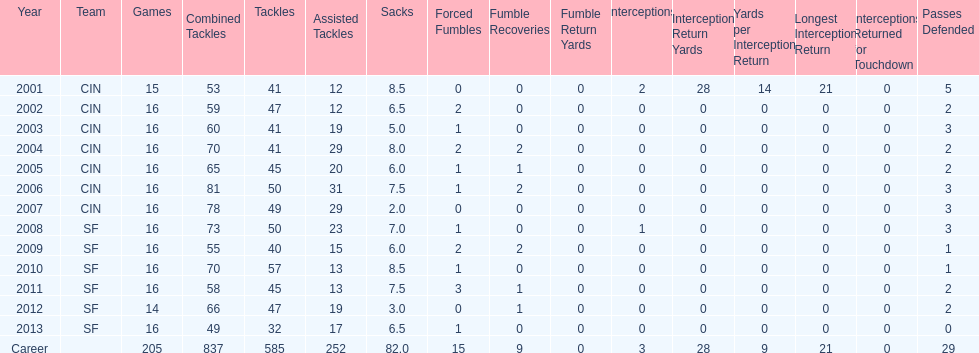Could you parse the entire table as a dict? {'header': ['Year', 'Team', 'Games', 'Combined Tackles', 'Tackles', 'Assisted Tackles', 'Sacks', 'Forced Fumbles', 'Fumble Recoveries', 'Fumble Return Yards', 'Interceptions', 'Interception Return Yards', 'Yards per Interception Return', 'Longest Interception Return', 'Interceptions Returned for Touchdown', 'Passes Defended'], 'rows': [['2001', 'CIN', '15', '53', '41', '12', '8.5', '0', '0', '0', '2', '28', '14', '21', '0', '5'], ['2002', 'CIN', '16', '59', '47', '12', '6.5', '2', '0', '0', '0', '0', '0', '0', '0', '2'], ['2003', 'CIN', '16', '60', '41', '19', '5.0', '1', '0', '0', '0', '0', '0', '0', '0', '3'], ['2004', 'CIN', '16', '70', '41', '29', '8.0', '2', '2', '0', '0', '0', '0', '0', '0', '2'], ['2005', 'CIN', '16', '65', '45', '20', '6.0', '1', '1', '0', '0', '0', '0', '0', '0', '2'], ['2006', 'CIN', '16', '81', '50', '31', '7.5', '1', '2', '0', '0', '0', '0', '0', '0', '3'], ['2007', 'CIN', '16', '78', '49', '29', '2.0', '0', '0', '0', '0', '0', '0', '0', '0', '3'], ['2008', 'SF', '16', '73', '50', '23', '7.0', '1', '0', '0', '1', '0', '0', '0', '0', '3'], ['2009', 'SF', '16', '55', '40', '15', '6.0', '2', '2', '0', '0', '0', '0', '0', '0', '1'], ['2010', 'SF', '16', '70', '57', '13', '8.5', '1', '0', '0', '0', '0', '0', '0', '0', '1'], ['2011', 'SF', '16', '58', '45', '13', '7.5', '3', '1', '0', '0', '0', '0', '0', '0', '2'], ['2012', 'SF', '14', '66', '47', '19', '3.0', '0', '1', '0', '0', '0', '0', '0', '0', '2'], ['2013', 'SF', '16', '49', '32', '17', '6.5', '1', '0', '0', '0', '0', '0', '0', '0', '0'], ['Career', '', '205', '837', '585', '252', '82.0', '15', '9', '0', '3', '28', '9', '21', '0', '29']]} What is the entire count of sacks made by smith? 82.0. 